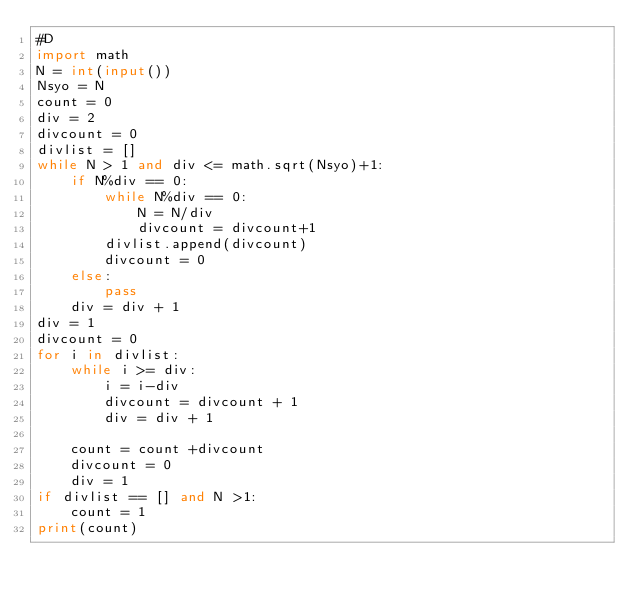Convert code to text. <code><loc_0><loc_0><loc_500><loc_500><_Python_>#D
import math
N = int(input())
Nsyo = N
count = 0
div = 2
divcount = 0
divlist = []
while N > 1 and div <= math.sqrt(Nsyo)+1:
    if N%div == 0:
        while N%div == 0:
            N = N/div
            divcount = divcount+1
        divlist.append(divcount)
        divcount = 0
    else:
        pass
    div = div + 1
div = 1
divcount = 0
for i in divlist:
    while i >= div:
        i = i-div
        divcount = divcount + 1
        div = div + 1
        
    count = count +divcount
    divcount = 0
    div = 1
if divlist == [] and N >1:
    count = 1
print(count)</code> 